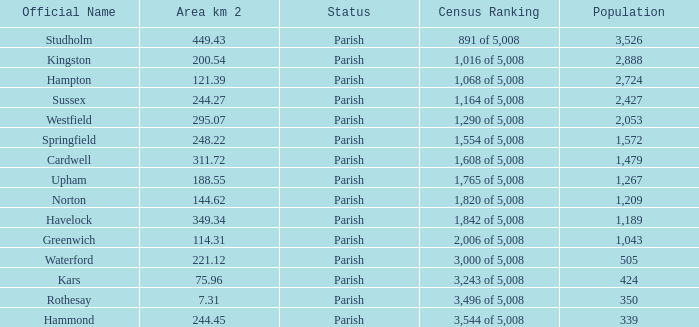What is the area in square kilometers of Studholm? 1.0. Would you be able to parse every entry in this table? {'header': ['Official Name', 'Area km 2', 'Status', 'Census Ranking', 'Population'], 'rows': [['Studholm', '449.43', 'Parish', '891 of 5,008', '3,526'], ['Kingston', '200.54', 'Parish', '1,016 of 5,008', '2,888'], ['Hampton', '121.39', 'Parish', '1,068 of 5,008', '2,724'], ['Sussex', '244.27', 'Parish', '1,164 of 5,008', '2,427'], ['Westfield', '295.07', 'Parish', '1,290 of 5,008', '2,053'], ['Springfield', '248.22', 'Parish', '1,554 of 5,008', '1,572'], ['Cardwell', '311.72', 'Parish', '1,608 of 5,008', '1,479'], ['Upham', '188.55', 'Parish', '1,765 of 5,008', '1,267'], ['Norton', '144.62', 'Parish', '1,820 of 5,008', '1,209'], ['Havelock', '349.34', 'Parish', '1,842 of 5,008', '1,189'], ['Greenwich', '114.31', 'Parish', '2,006 of 5,008', '1,043'], ['Waterford', '221.12', 'Parish', '3,000 of 5,008', '505'], ['Kars', '75.96', 'Parish', '3,243 of 5,008', '424'], ['Rothesay', '7.31', 'Parish', '3,496 of 5,008', '350'], ['Hammond', '244.45', 'Parish', '3,544 of 5,008', '339']]} 